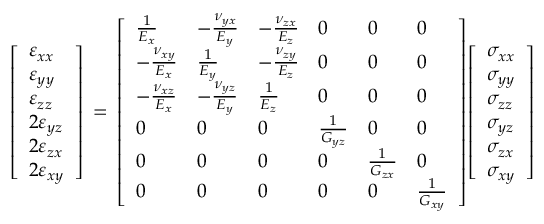Convert formula to latex. <formula><loc_0><loc_0><loc_500><loc_500>{ \left [ \begin{array} { l } { \varepsilon _ { x x } } \\ { \varepsilon _ { y y } } \\ { \varepsilon _ { z z } } \\ { 2 \varepsilon _ { y z } } \\ { 2 \varepsilon _ { z x } } \\ { 2 \varepsilon _ { x y } } \end{array} \right ] } \, = \, { \left [ \begin{array} { l l l l l l } { { \frac { 1 } { E _ { x } } } } & { - { \frac { \nu _ { y x } } { E _ { y } } } } & { - { \frac { \nu _ { z x } } { E _ { z } } } } & { 0 } & { 0 } & { 0 } \\ { - { \frac { \nu _ { x y } } { E _ { x } } } } & { { \frac { 1 } { E _ { y } } } } & { - { \frac { \nu _ { z y } } { E _ { z } } } } & { 0 } & { 0 } & { 0 } \\ { - { \frac { \nu _ { x z } } { E _ { x } } } } & { - { \frac { \nu _ { y z } } { E _ { y } } } } & { { \frac { 1 } { E _ { z } } } } & { 0 } & { 0 } & { 0 } \\ { 0 } & { 0 } & { 0 } & { { \frac { 1 } { G _ { y z } } } } & { 0 } & { 0 } \\ { 0 } & { 0 } & { 0 } & { 0 } & { { \frac { 1 } { G _ { z x } } } } & { 0 } \\ { 0 } & { 0 } & { 0 } & { 0 } & { 0 } & { { \frac { 1 } { G _ { x y } } } } \end{array} \right ] } { \left [ \begin{array} { l } { \sigma _ { x x } } \\ { \sigma _ { y y } } \\ { \sigma _ { z z } } \\ { \sigma _ { y z } } \\ { \sigma _ { z x } } \\ { \sigma _ { x y } } \end{array} \right ] }</formula> 